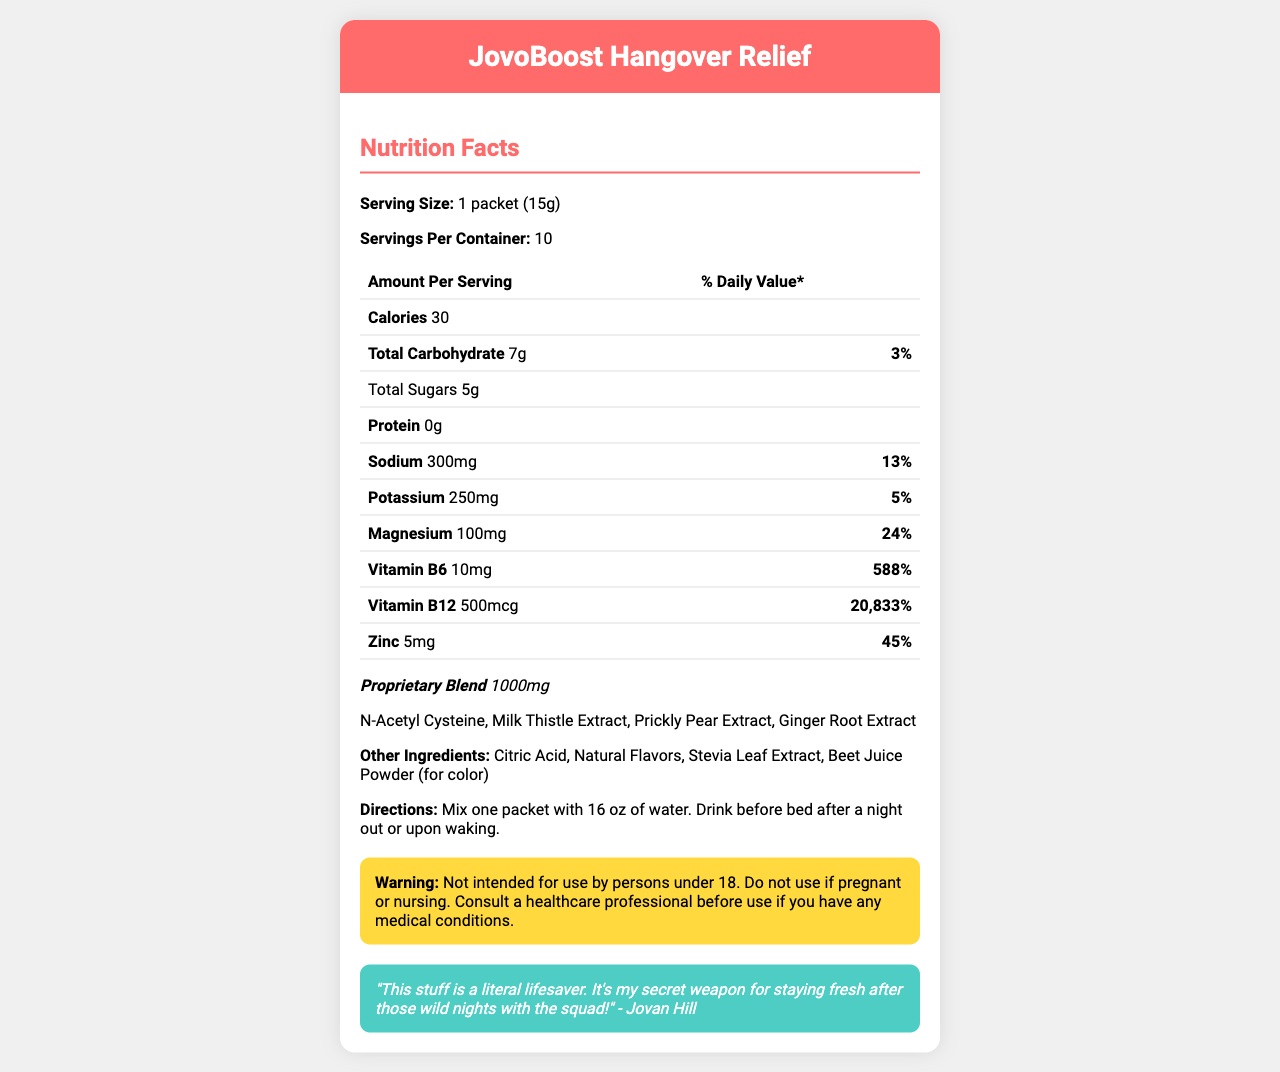what is the serving size of JovoBoost Hangover Relief? The document clearly states the serving size is "1 packet (15g)".
Answer: 1 packet (15g) how many servings are there per container? The document specifies that there are 10 servings per container.
Answer: 10 servings how many calories are there per serving? Under the nutrition facts, it lists that each serving contains 30 calories.
Answer: 30 calories how much sodium is in one serving? The nutrition facts label states that one serving contains 300mg of sodium.
Answer: 300mg what is the daily value percentage of magnesium in one serving? The document shows that magnesium in one serving has a daily value percentage of 24%.
Answer: 24% which ingredient provides the highest daily value percentage? A. Sodium B. Potassium C. Magnesium D. Zinc E. Vitamin B12 The document indicates that Vitamin B12 has the highest daily value percentage at 20,833%.
Answer: E. Vitamin B12 what is the amount of total carbohydrates per serving? A. 5g B. 7g C. 10g D. 12g The document lists total carbohydrates as 7g per serving.
Answer: B. 7g Is there any protein in the JovoBoost Hangover Relief? The nutrition facts label indicates that the amount of protein is 0g.
Answer: No is this product intended for use by persons under 18? The warning section states that the product is not intended for use by persons under 18.
Answer: No summarize the main idea of the document. The document in question lays out various details about JovoBoost Hangover Relief, including its nutritional information, how to use it, and specific warnings. The aim is to offer a detailed view into its components, especially the electrolytes, vital in hangover recovery as claimed by Jovan and friends.
Answer: The document provides the nutrition facts, directions, warning, and a quote for JovoBoost Hangover Relief, a supplement meant to aid with hangover recovery. It highlights key ingredients and their daily values, especially focusing on electrolytes like sodium, potassium, and magnesium. what flavor is JovoBoost Hangover Relief? The document does not mention the specific flavor of the supplement.
Answer: Not enough information what are the proprietary blend ingredients? The document lists these ingredients under the proprietary blend section.
Answer: N-Acetyl Cysteine, Milk Thistle Extract, Prickly Pear Extract, Ginger Root Extract 